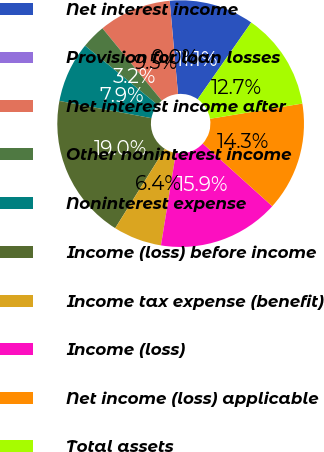Convert chart. <chart><loc_0><loc_0><loc_500><loc_500><pie_chart><fcel>Net interest income<fcel>Provision for loan losses<fcel>Net interest income after<fcel>Other noninterest income<fcel>Noninterest expense<fcel>Income (loss) before income<fcel>Income tax expense (benefit)<fcel>Income (loss)<fcel>Net income (loss) applicable<fcel>Total assets<nl><fcel>11.11%<fcel>0.0%<fcel>9.52%<fcel>3.18%<fcel>7.94%<fcel>19.04%<fcel>6.35%<fcel>15.87%<fcel>14.28%<fcel>12.7%<nl></chart> 